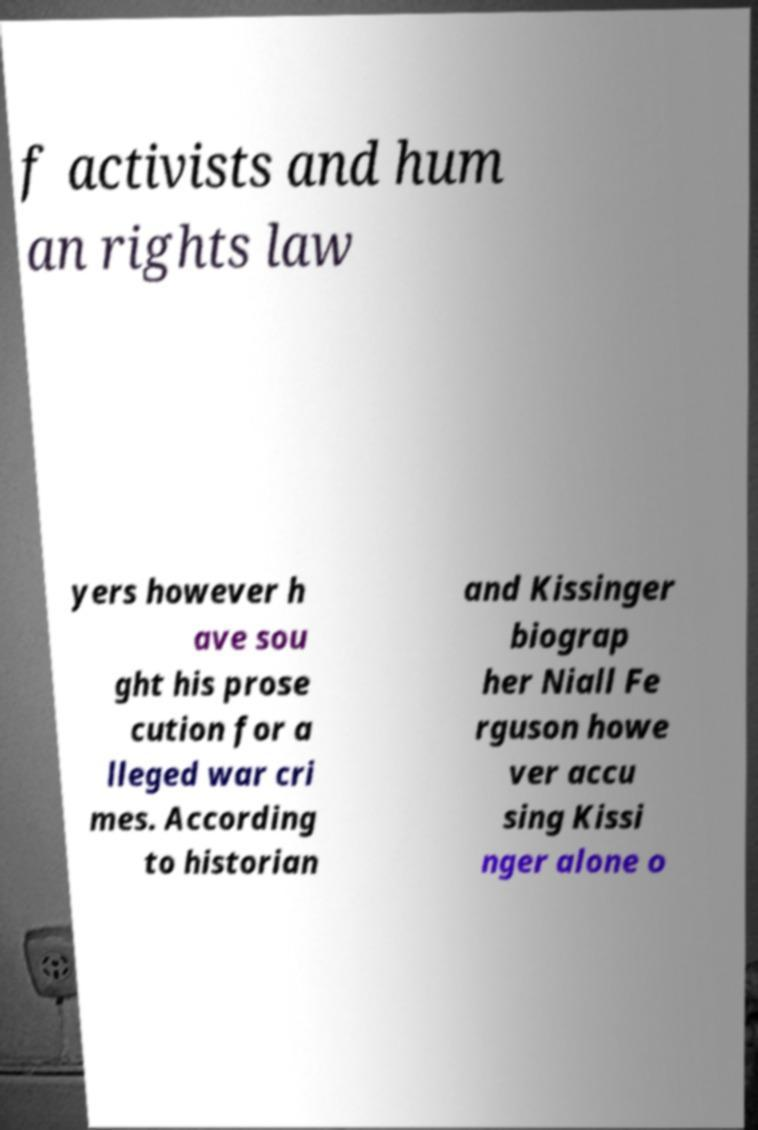Please identify and transcribe the text found in this image. f activists and hum an rights law yers however h ave sou ght his prose cution for a lleged war cri mes. According to historian and Kissinger biograp her Niall Fe rguson howe ver accu sing Kissi nger alone o 